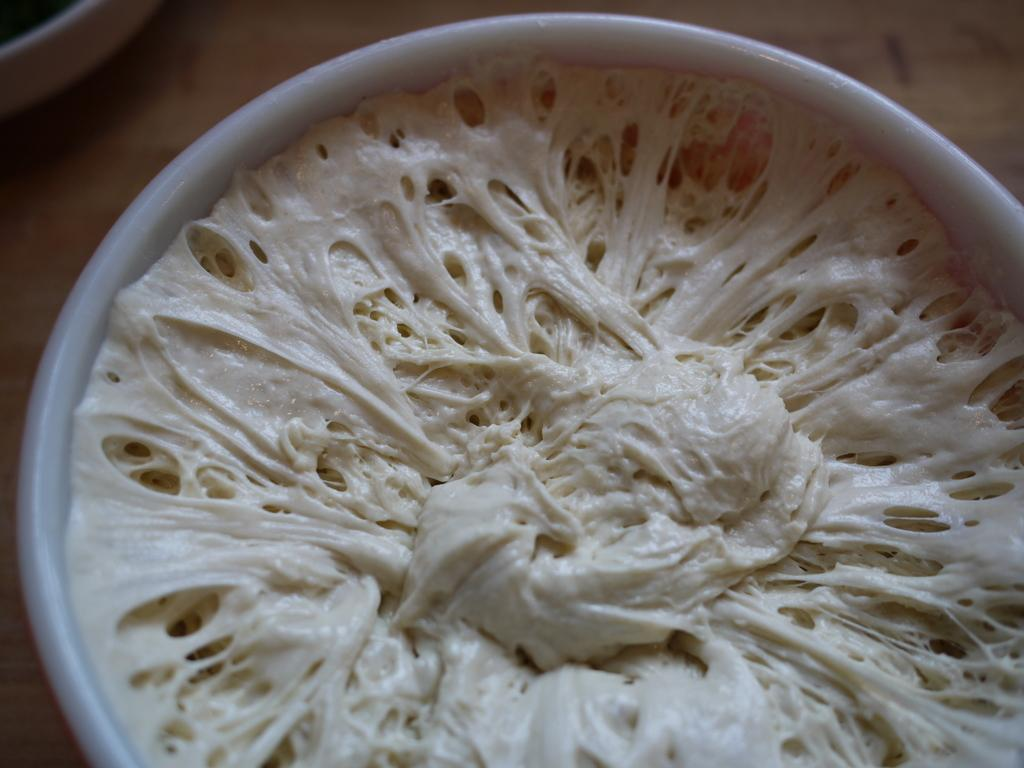What is in the bowl that is visible in the image? There are food items in a bowl. Where is the bowl located in the image? The bowl is placed on a table. What type of sponge can be seen floating in the air in the image? There is no sponge present in the image, and the food items are not floating in the air. 